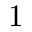Convert formula to latex. <formula><loc_0><loc_0><loc_500><loc_500>1</formula> 